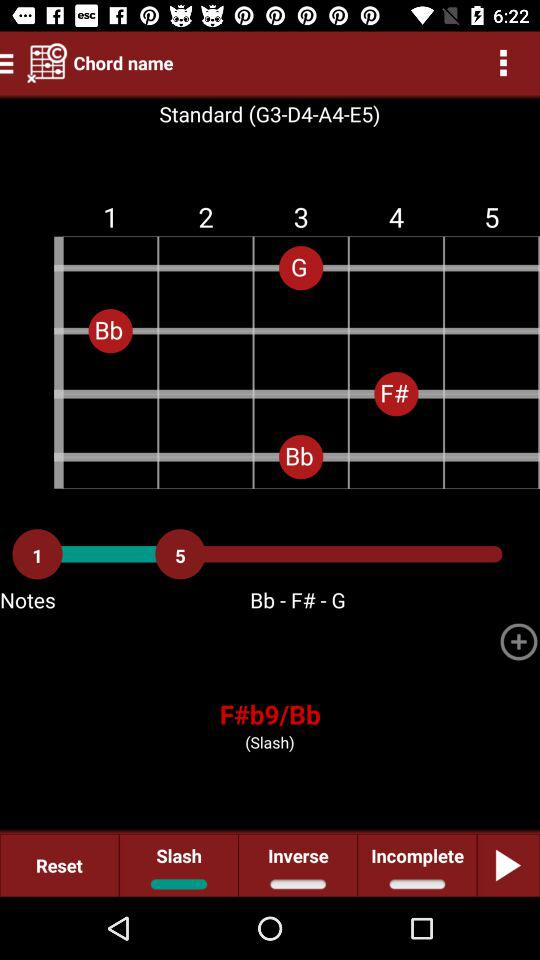How many total notes are there? There are 5 notes. 